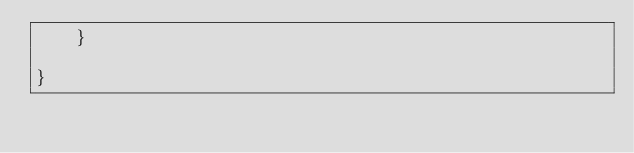<code> <loc_0><loc_0><loc_500><loc_500><_Swift_>    }

}
</code> 